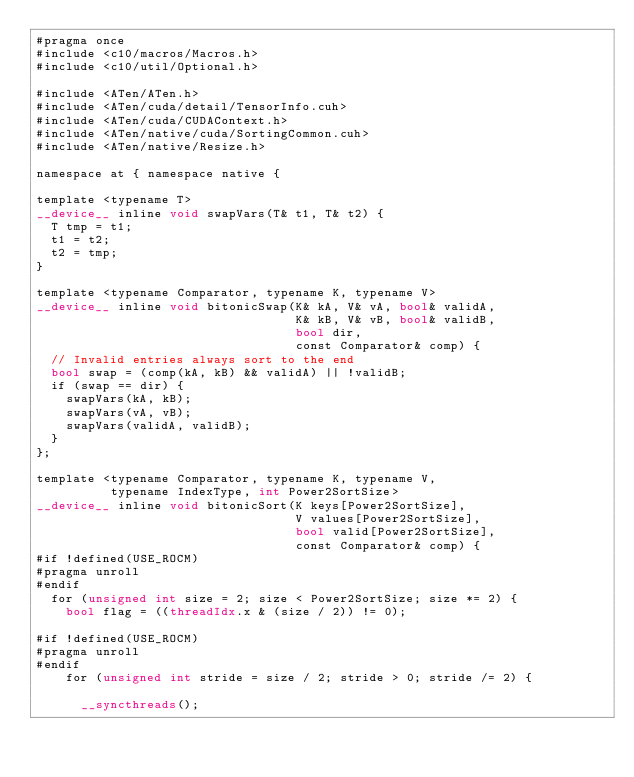<code> <loc_0><loc_0><loc_500><loc_500><_Cuda_>#pragma once
#include <c10/macros/Macros.h>
#include <c10/util/Optional.h>

#include <ATen/ATen.h>
#include <ATen/cuda/detail/TensorInfo.cuh>
#include <ATen/cuda/CUDAContext.h>
#include <ATen/native/cuda/SortingCommon.cuh>
#include <ATen/native/Resize.h>

namespace at { namespace native {

template <typename T>
__device__ inline void swapVars(T& t1, T& t2) {
  T tmp = t1;
  t1 = t2;
  t2 = tmp;
}

template <typename Comparator, typename K, typename V>
__device__ inline void bitonicSwap(K& kA, V& vA, bool& validA,
                                   K& kB, V& vB, bool& validB,
                                   bool dir,
                                   const Comparator& comp) {
  // Invalid entries always sort to the end
  bool swap = (comp(kA, kB) && validA) || !validB;
  if (swap == dir) {
    swapVars(kA, kB);
    swapVars(vA, vB);
    swapVars(validA, validB);
  }
};

template <typename Comparator, typename K, typename V,
          typename IndexType, int Power2SortSize>
__device__ inline void bitonicSort(K keys[Power2SortSize],
                                   V values[Power2SortSize],
                                   bool valid[Power2SortSize],
                                   const Comparator& comp) {
#if !defined(USE_ROCM)
#pragma unroll
#endif
  for (unsigned int size = 2; size < Power2SortSize; size *= 2) {
    bool flag = ((threadIdx.x & (size / 2)) != 0);

#if !defined(USE_ROCM)
#pragma unroll
#endif
    for (unsigned int stride = size / 2; stride > 0; stride /= 2) {

      __syncthreads();
</code> 